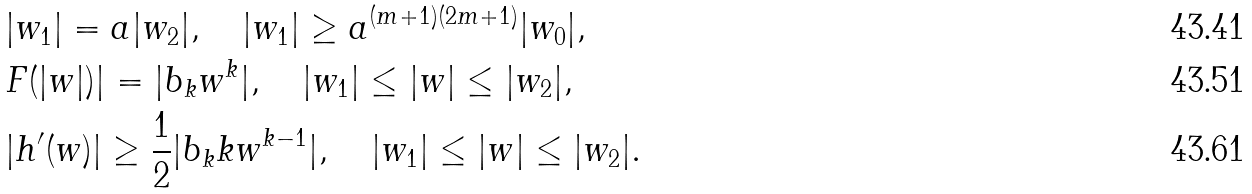<formula> <loc_0><loc_0><loc_500><loc_500>& | w _ { 1 } | = a | w _ { 2 } | , \quad | w _ { 1 } | \geq a ^ { ( m + 1 ) ( 2 m + 1 ) } | w _ { 0 } | , \\ & F ( | w | ) | = | b _ { k } w ^ { k } | , \quad | w _ { 1 } | \leq | w | \leq | w _ { 2 } | , \\ & | h ^ { \prime } ( w ) | \geq \frac { 1 } { 2 } | b _ { k } k w ^ { k - 1 } | , \quad | w _ { 1 } | \leq | w | \leq | w _ { 2 } | .</formula> 